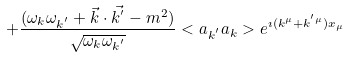<formula> <loc_0><loc_0><loc_500><loc_500>+ \frac { ( \omega _ { k } \omega _ { k ^ { ^ { \prime } } } + \vec { k } \cdot \vec { k ^ { ^ { \prime } } } - m ^ { 2 } ) } { \sqrt { \omega _ { k } \omega _ { k ^ { ^ { \prime } } } } } < a _ { k ^ { ^ { \prime } } } a _ { k } > e ^ { \imath ( k ^ { \mu } + k ^ { ^ { \prime } \mu } ) x _ { \mu } }</formula> 